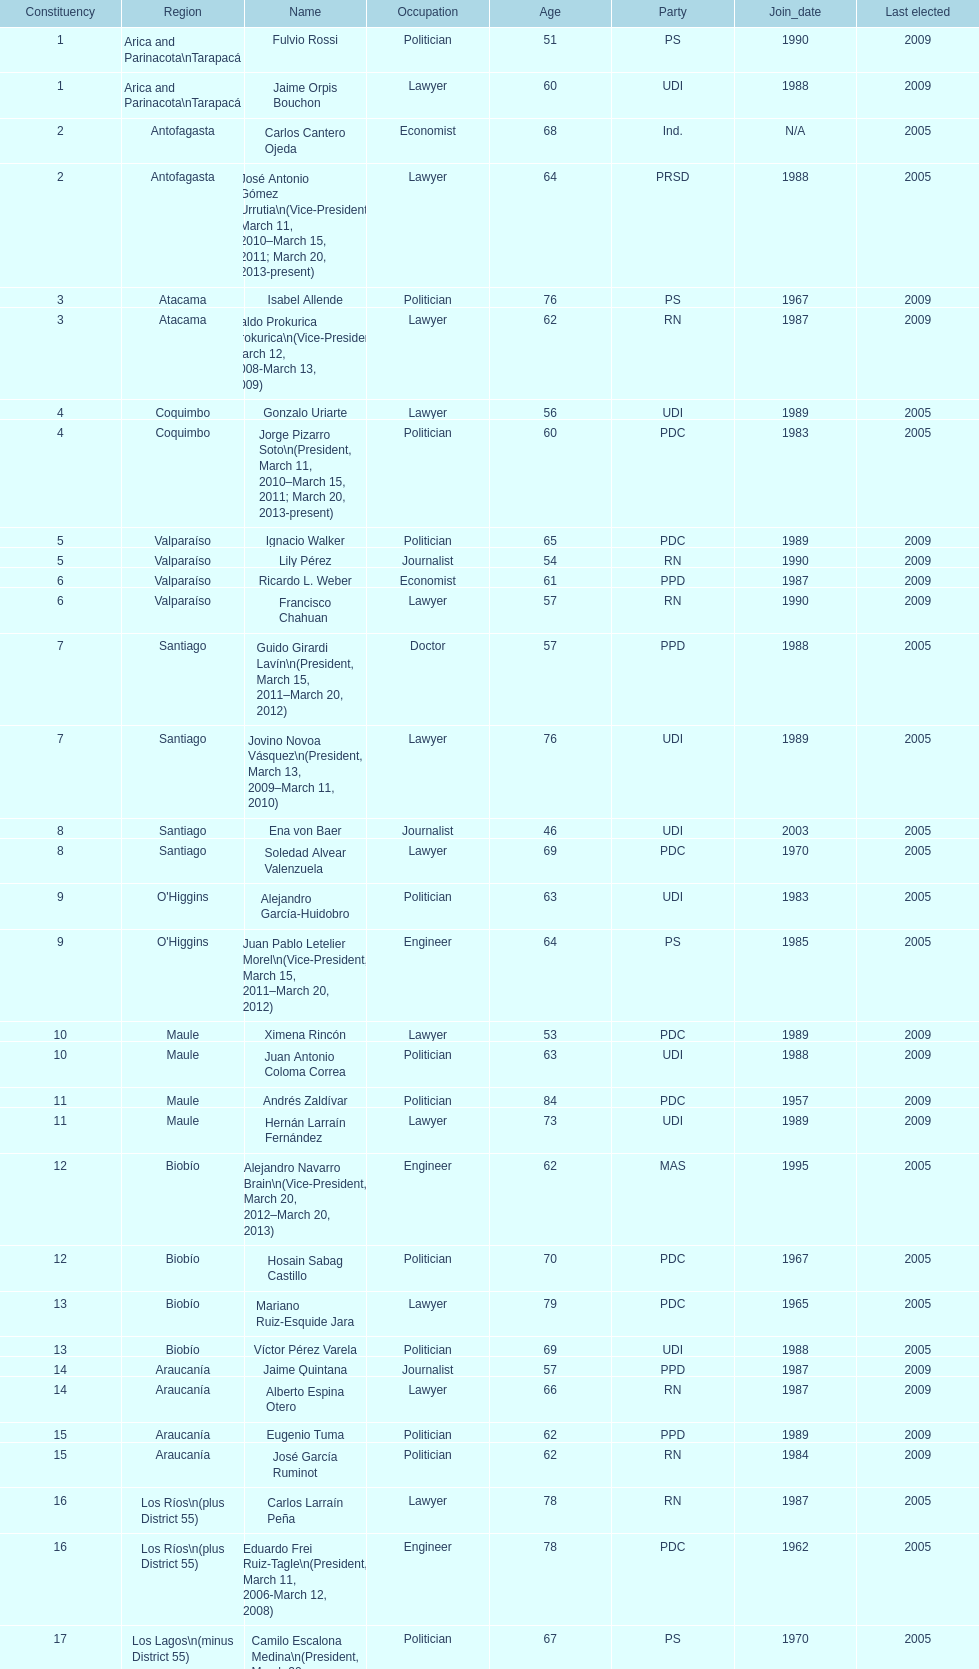How long was baldo prokurica prokurica vice-president? 1 year. 